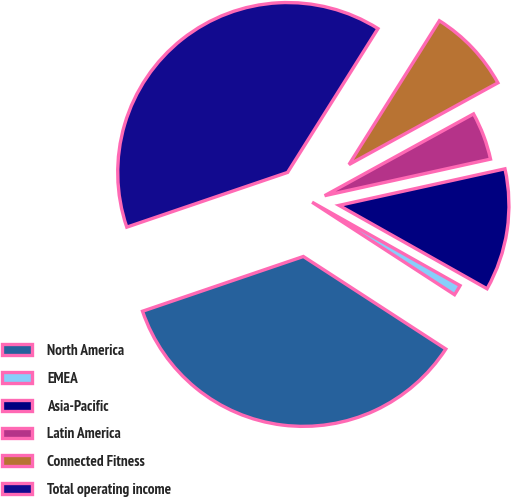Convert chart. <chart><loc_0><loc_0><loc_500><loc_500><pie_chart><fcel>North America<fcel>EMEA<fcel>Asia-Pacific<fcel>Latin America<fcel>Connected Fitness<fcel>Total operating income<nl><fcel>35.62%<fcel>1.0%<fcel>11.62%<fcel>4.54%<fcel>8.08%<fcel>39.16%<nl></chart> 